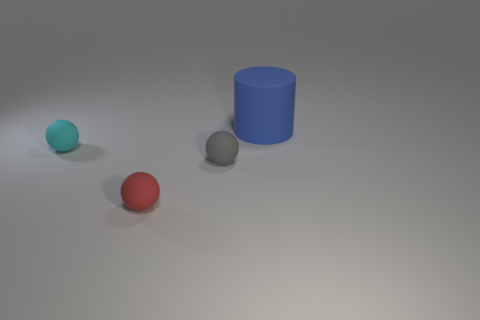Add 1 large metal cylinders. How many objects exist? 5 Subtract 1 balls. How many balls are left? 2 Subtract all balls. How many objects are left? 1 Subtract 0 gray cylinders. How many objects are left? 4 Subtract all small green metal blocks. Subtract all rubber things. How many objects are left? 0 Add 2 gray matte things. How many gray matte things are left? 3 Add 4 gray things. How many gray things exist? 5 